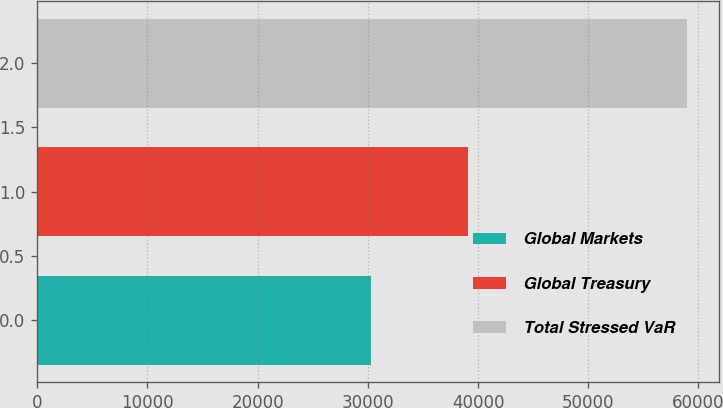Convert chart to OTSL. <chart><loc_0><loc_0><loc_500><loc_500><bar_chart><fcel>Global Markets<fcel>Global Treasury<fcel>Total Stressed VaR<nl><fcel>30255<fcel>39050<fcel>58945<nl></chart> 